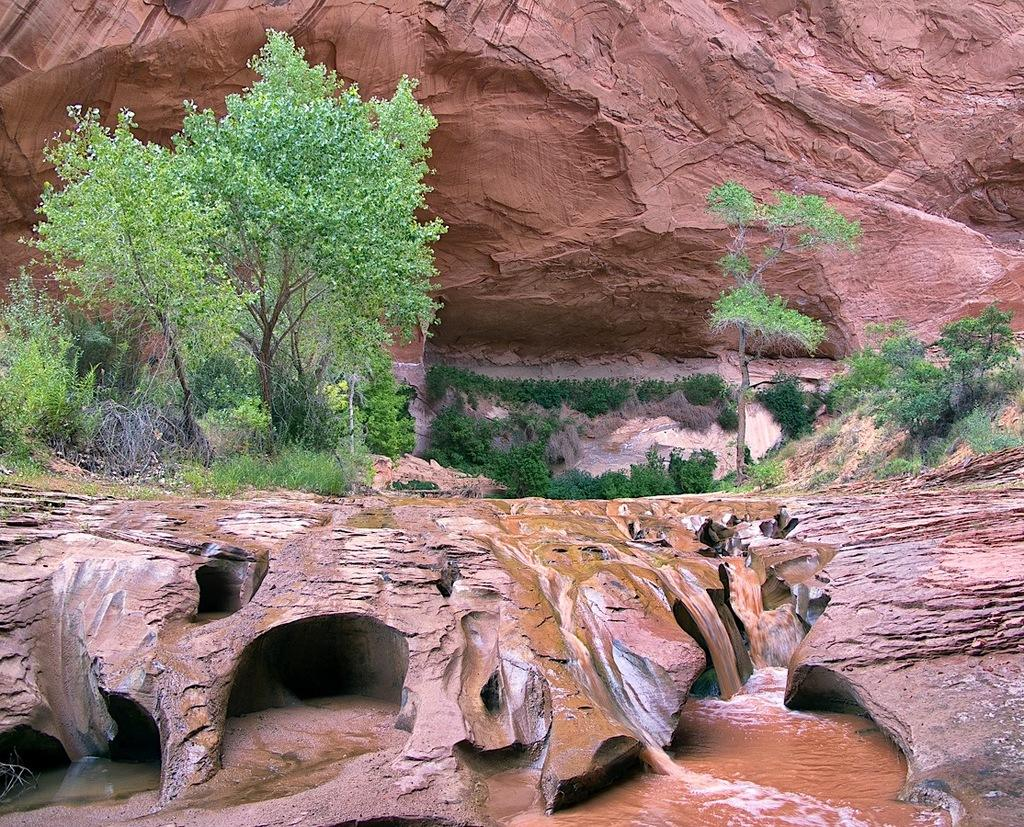What is flowing from the rocks in the image? Water is flowing from the rocks in the image. What type of vegetation is visible in the image? There is grass visible in the image. What can be seen in the background of the image? There are trees and rock hills in the background of the image. How does the water start flowing in the image? The water is already flowing in the image, so there is no indication of how it started. 